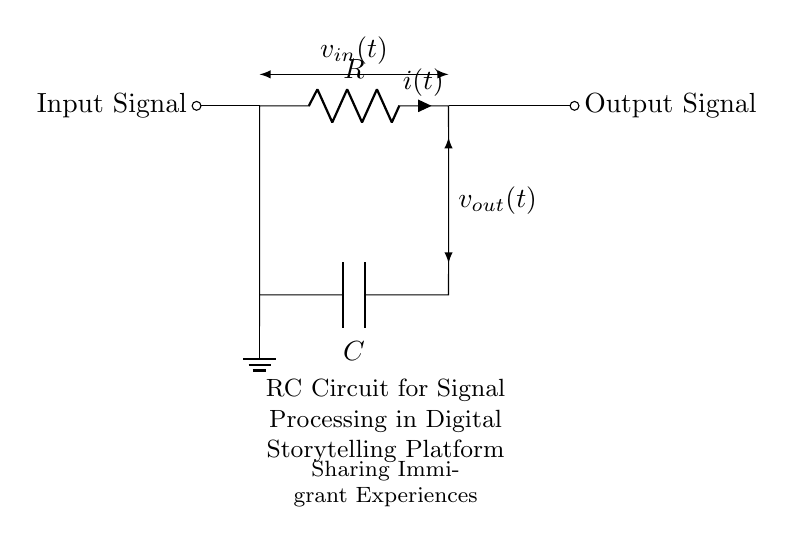What type of circuit is represented here? The circuit is an RC circuit, which consists of a resistor and a capacitor connected in series.
Answer: RC circuit What is the label of the capacitor in this circuit? The capacitor in the circuit is labeled C.
Answer: C What does the variable i(t) represent in this circuit? The variable i(t) represents the instantaneous current flowing through the resistor at any given time.
Answer: Instantaneous current What is the relationship between the input and output voltages in this RC circuit? The output voltage is derived from the input voltage, and given that the circuit filters the input signal, the output voltage will have a time-dependent response based on the RC time constant.
Answer: Time-dependent response What is the purpose of the RC circuit in the context of digital storytelling? The RC circuit is used for signal processing, which helps in shaping and filtering the input signals to enhance audio or visual quality in digital storytelling.
Answer: Signal processing What happens to the output voltage when the input voltage is increased? When the input voltage is increased, the output voltage will also increase, but it will follow the RC time constant which governs how quickly the voltage changes.
Answer: It increases following the RC time constant What is the function of the resistor in this RC circuit? The resistor limits the current flow and helps to determine the time constant along with the capacitor, which affects the charging and discharging behaviors in the circuit.
Answer: Limits current flow 